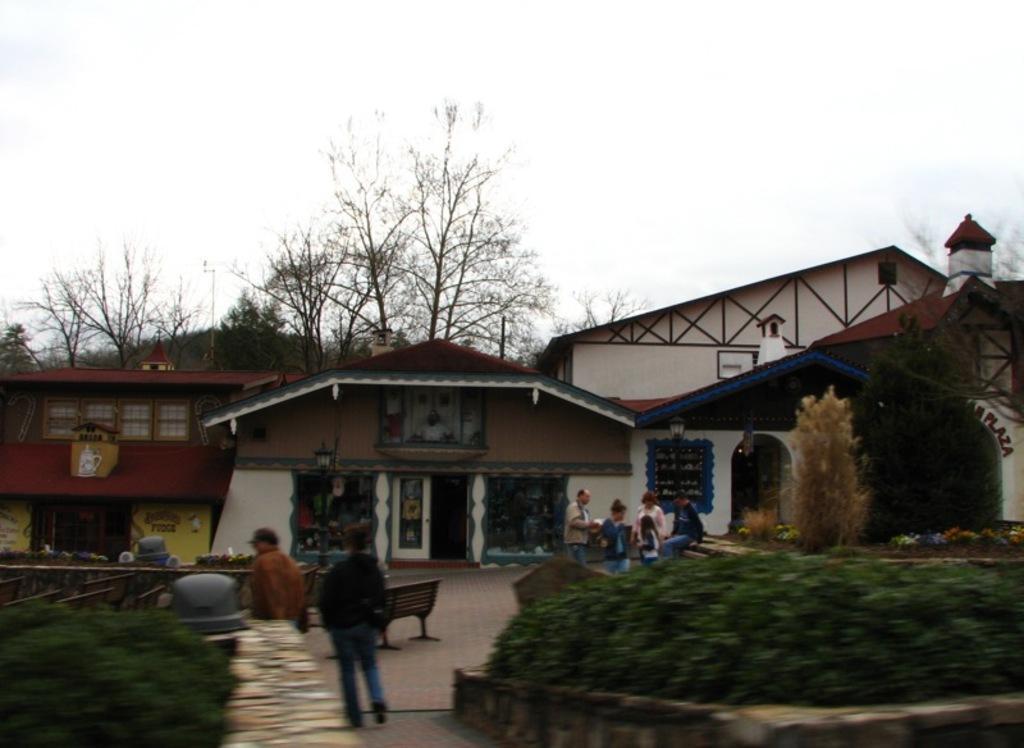Could you give a brief overview of what you see in this image? In the picture we can see some houses with doors and near it, we can see some people are standing and near to them, we can see some plant bushes and behind the houses we can see some trees and the sky. 